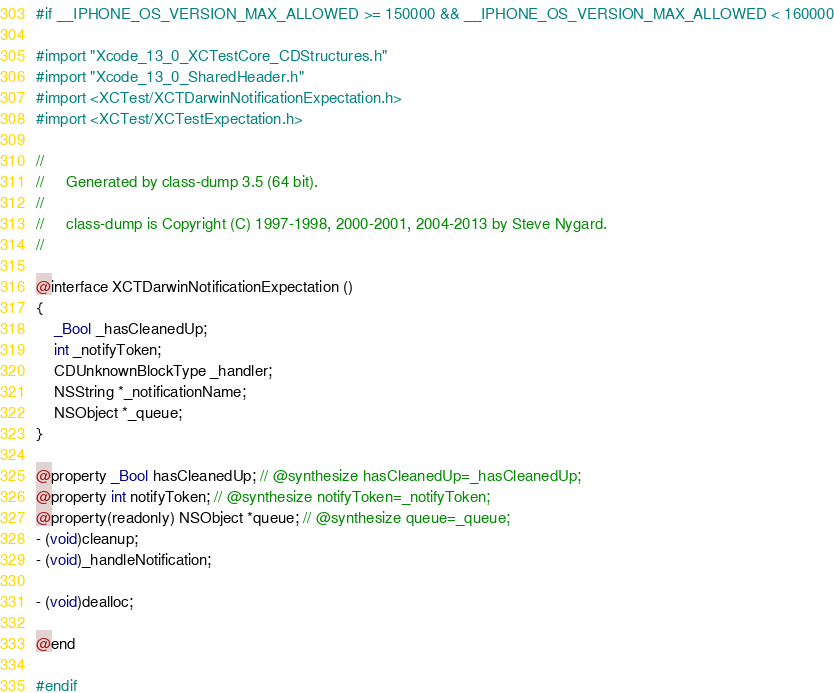Convert code to text. <code><loc_0><loc_0><loc_500><loc_500><_C_>#if __IPHONE_OS_VERSION_MAX_ALLOWED >= 150000 && __IPHONE_OS_VERSION_MAX_ALLOWED < 160000

#import "Xcode_13_0_XCTestCore_CDStructures.h"
#import "Xcode_13_0_SharedHeader.h"
#import <XCTest/XCTDarwinNotificationExpectation.h>
#import <XCTest/XCTestExpectation.h>

//
//     Generated by class-dump 3.5 (64 bit).
//
//     class-dump is Copyright (C) 1997-1998, 2000-2001, 2004-2013 by Steve Nygard.
//

@interface XCTDarwinNotificationExpectation ()
{
    _Bool _hasCleanedUp;
    int _notifyToken;
    CDUnknownBlockType _handler;
    NSString *_notificationName;
    NSObject *_queue;
}

@property _Bool hasCleanedUp; // @synthesize hasCleanedUp=_hasCleanedUp;
@property int notifyToken; // @synthesize notifyToken=_notifyToken;
@property(readonly) NSObject *queue; // @synthesize queue=_queue;
- (void)cleanup;
- (void)_handleNotification;

- (void)dealloc;

@end

#endif</code> 